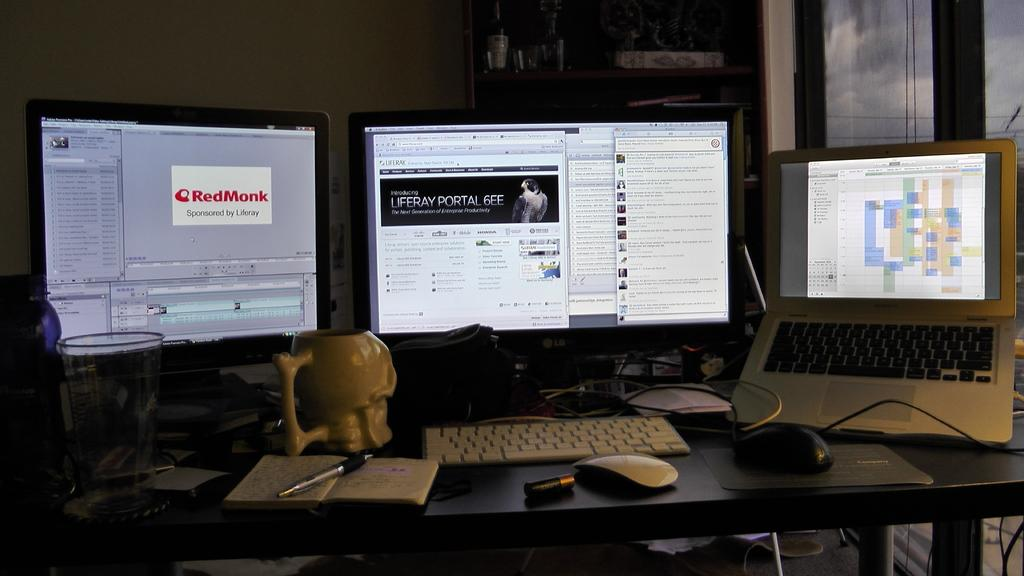<image>
Present a compact description of the photo's key features. A computer monitor has the RedMonk logo on it. 